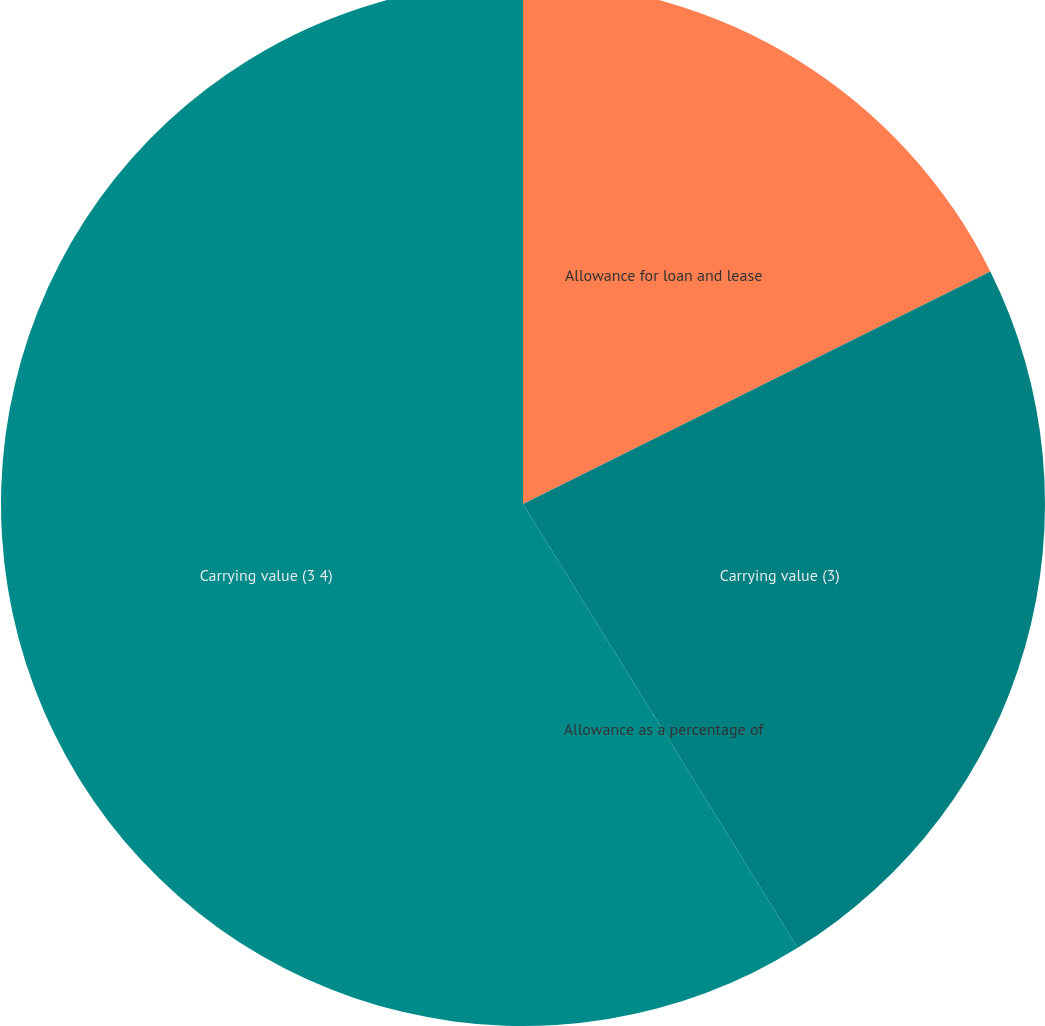Convert chart to OTSL. <chart><loc_0><loc_0><loc_500><loc_500><pie_chart><fcel>Allowance for loan and lease<fcel>Carrying value (3)<fcel>Allowance as a percentage of<fcel>Carrying value (3 4)<nl><fcel>17.65%<fcel>23.53%<fcel>0.0%<fcel>58.82%<nl></chart> 